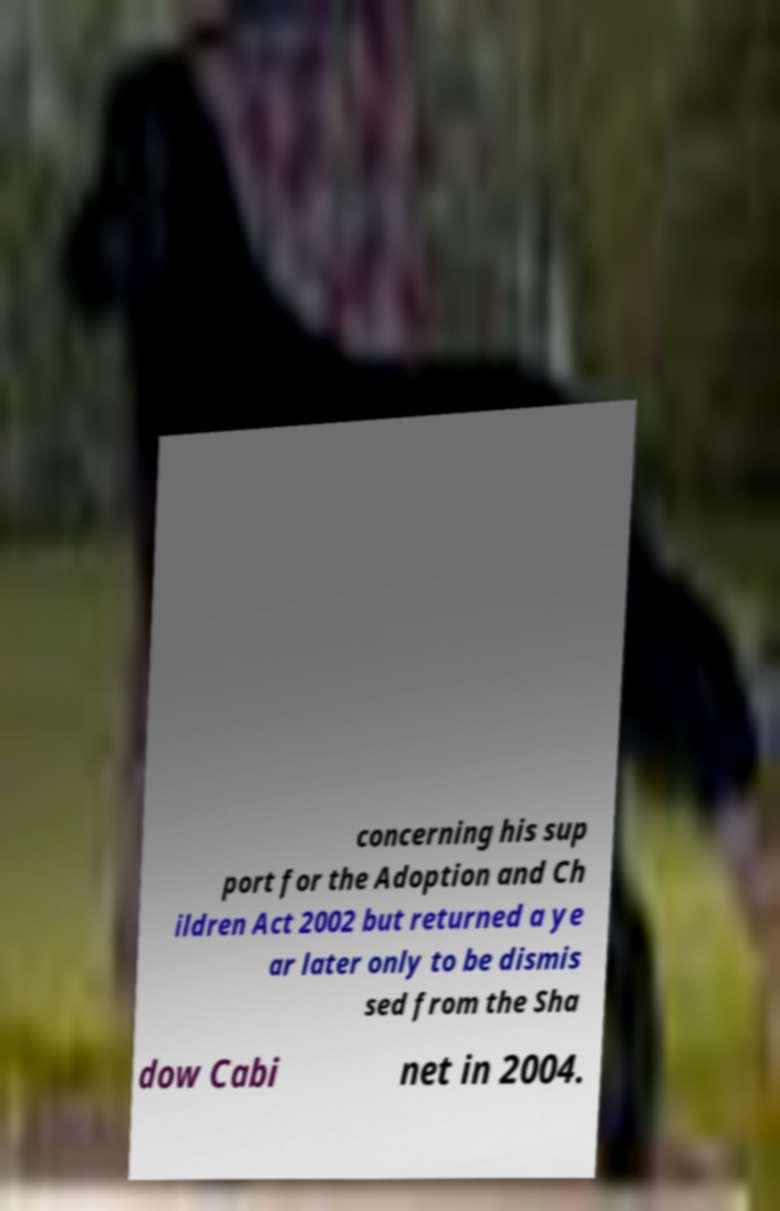Please read and relay the text visible in this image. What does it say? concerning his sup port for the Adoption and Ch ildren Act 2002 but returned a ye ar later only to be dismis sed from the Sha dow Cabi net in 2004. 